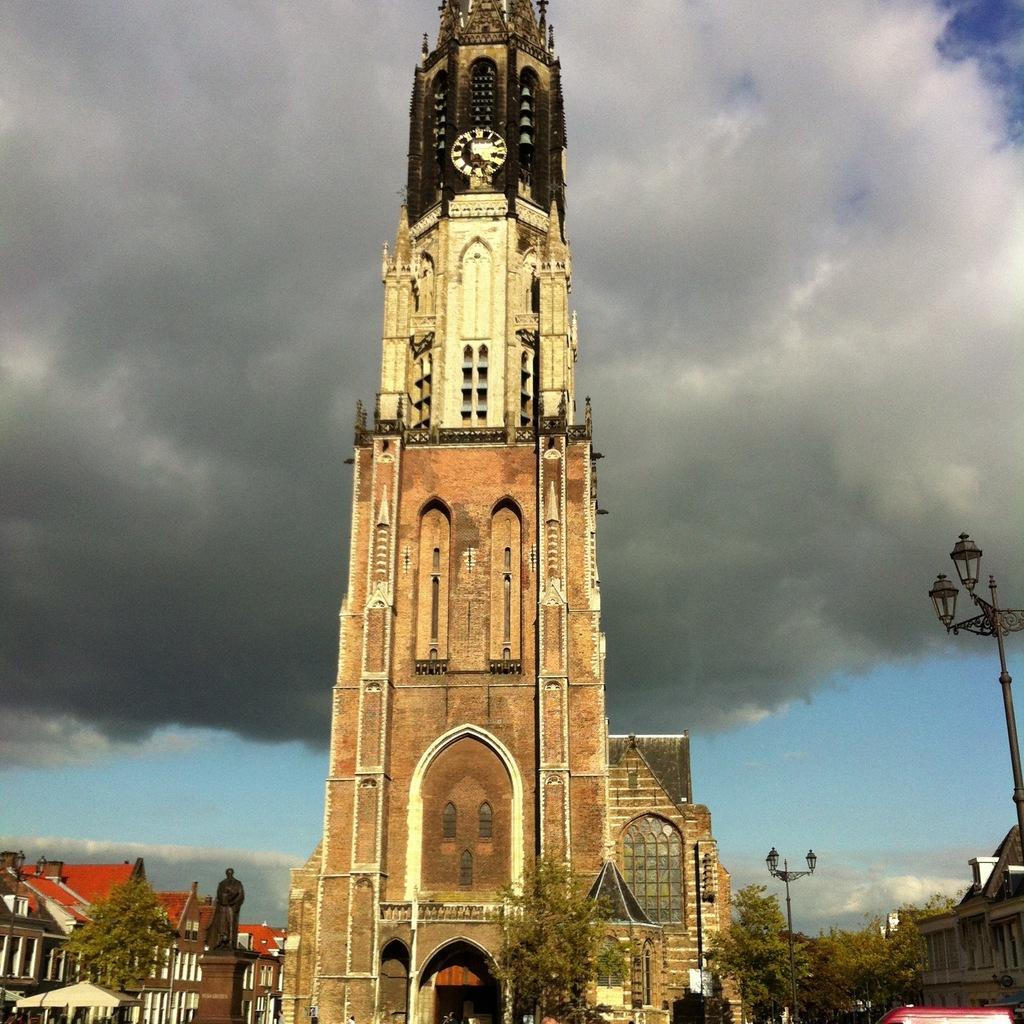Please provide a concise description of this image. This is an outside view. in the middle of the image there is a clock tower. At the bottom there are many buildings, trees and light poles. In the bottom left there is a statue on a pillar. At the top of the image I can see the sky and clouds. 